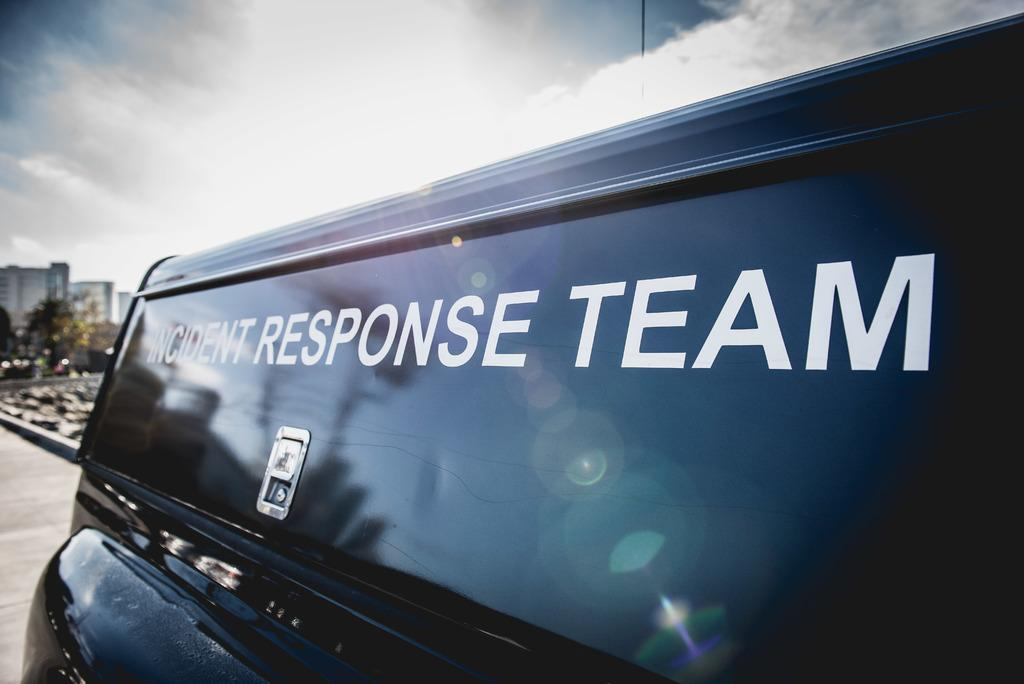What is the main subject of the image? There is a vehicle in the image. What can be seen in the background of the image? There are buildings, trees, and the sky visible in the background of the image. Are there any clouds in the sky? Yes, clouds are present in the sky. What type of patch can be seen on the chin of the vehicle in the image? There is no patch or chin present on the vehicle in the image; it is a vehicle, not a person or animal. 